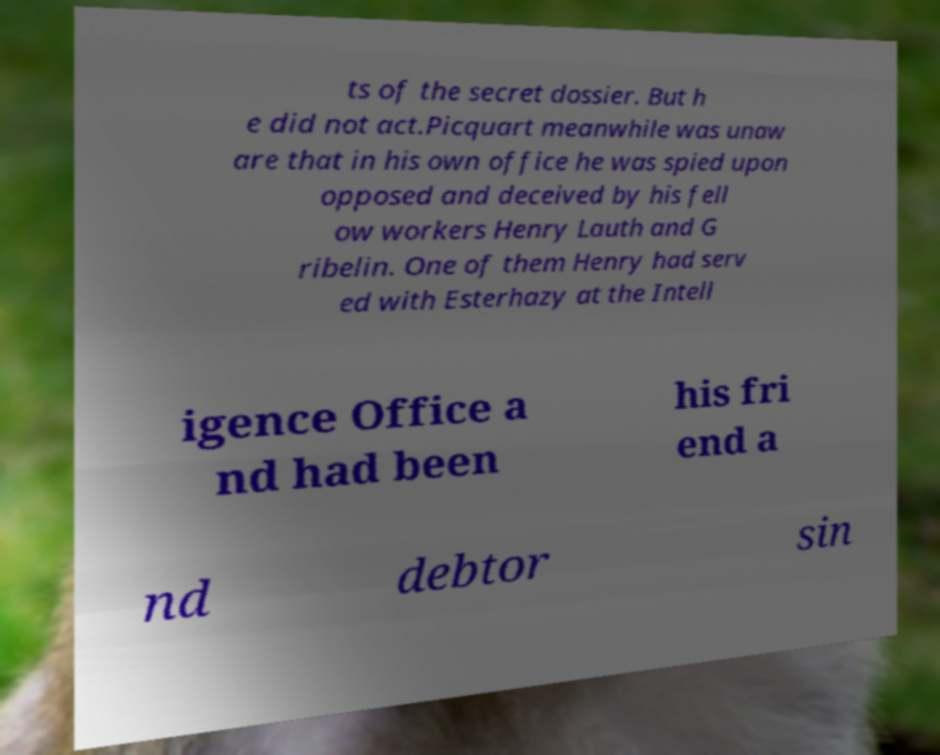Please identify and transcribe the text found in this image. ts of the secret dossier. But h e did not act.Picquart meanwhile was unaw are that in his own office he was spied upon opposed and deceived by his fell ow workers Henry Lauth and G ribelin. One of them Henry had serv ed with Esterhazy at the Intell igence Office a nd had been his fri end a nd debtor sin 